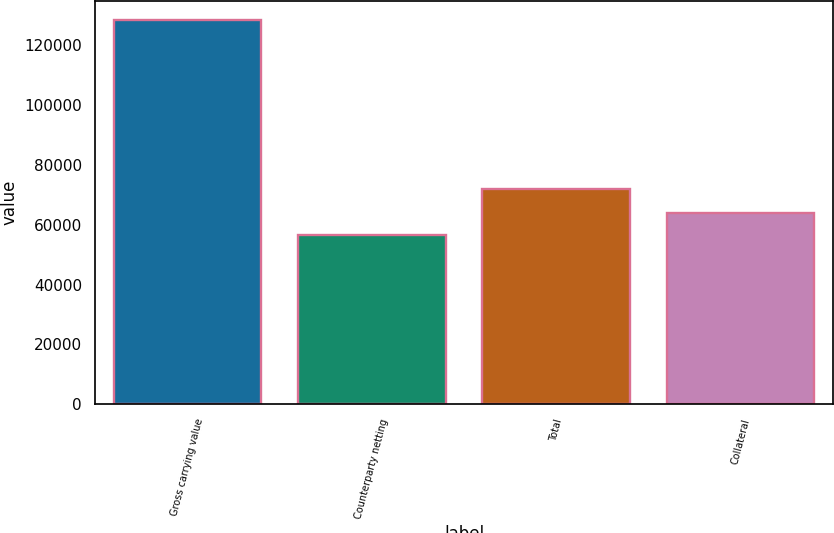<chart> <loc_0><loc_0><loc_500><loc_500><bar_chart><fcel>Gross carrying value<fcel>Counterparty netting<fcel>Total<fcel>Collateral<nl><fcel>128452<fcel>56636<fcel>71816<fcel>63817.6<nl></chart> 